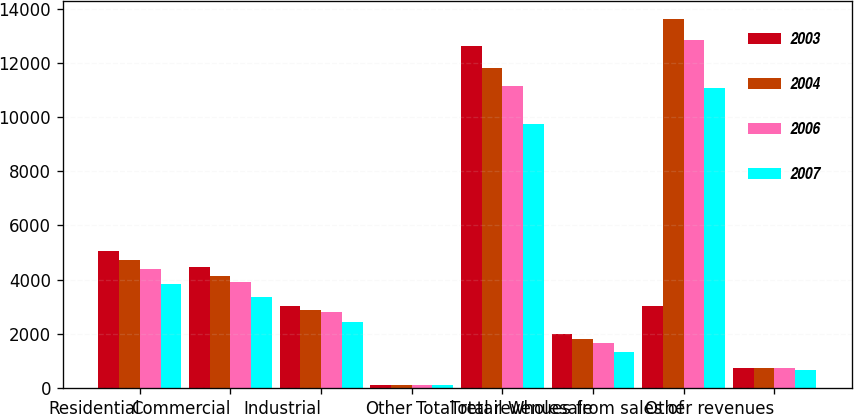Convert chart. <chart><loc_0><loc_0><loc_500><loc_500><stacked_bar_chart><ecel><fcel>Residential<fcel>Commercial<fcel>Industrial<fcel>Other<fcel>Total retail<fcel>Wholesale<fcel>Total revenues from sales of<fcel>Other revenues<nl><fcel>2003<fcel>5045<fcel>4467<fcel>3020<fcel>107<fcel>12639<fcel>1988<fcel>3020<fcel>726<nl><fcel>2004<fcel>4716<fcel>4117<fcel>2866<fcel>102<fcel>11801<fcel>1822<fcel>13623<fcel>733<nl><fcel>2006<fcel>4376<fcel>3904<fcel>2785<fcel>100<fcel>11165<fcel>1667<fcel>12832<fcel>722<nl><fcel>2007<fcel>3848<fcel>3346<fcel>2446<fcel>92<fcel>9732<fcel>1341<fcel>11073<fcel>656<nl></chart> 